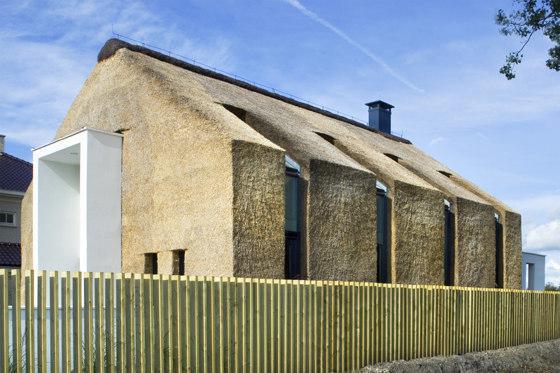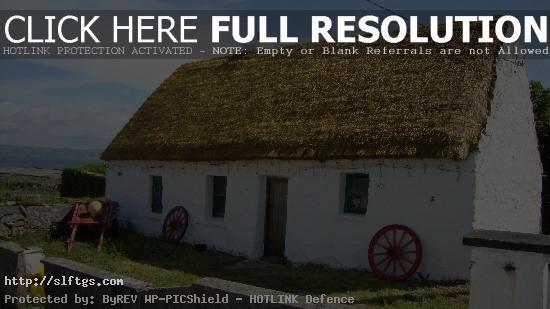The first image is the image on the left, the second image is the image on the right. Evaluate the accuracy of this statement regarding the images: "A fence runs alongside the building in the image on the left.". Is it true? Answer yes or no. Yes. 